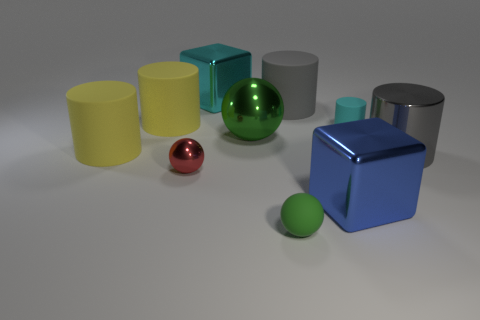Is the number of red spheres greater than the number of large yellow cylinders?
Offer a terse response. No. What is the color of the ball that is behind the big gray shiny object?
Make the answer very short. Green. What is the size of the matte thing that is both in front of the gray rubber thing and on the right side of the green rubber sphere?
Your answer should be very brief. Small. What number of red things are the same size as the green rubber object?
Your answer should be compact. 1. What material is the small red thing that is the same shape as the large green shiny thing?
Your answer should be very brief. Metal. Is the shape of the blue object the same as the big cyan thing?
Keep it short and to the point. Yes. There is a cyan rubber object; how many large blue blocks are to the left of it?
Offer a very short reply. 1. There is a gray object that is left of the big shiny block that is in front of the large cyan metal thing; what shape is it?
Keep it short and to the point. Cylinder. What is the shape of the green object that is made of the same material as the tiny cylinder?
Offer a very short reply. Sphere. There is a rubber thing that is on the right side of the blue shiny thing; does it have the same size as the green sphere that is in front of the big blue block?
Ensure brevity in your answer.  Yes. 